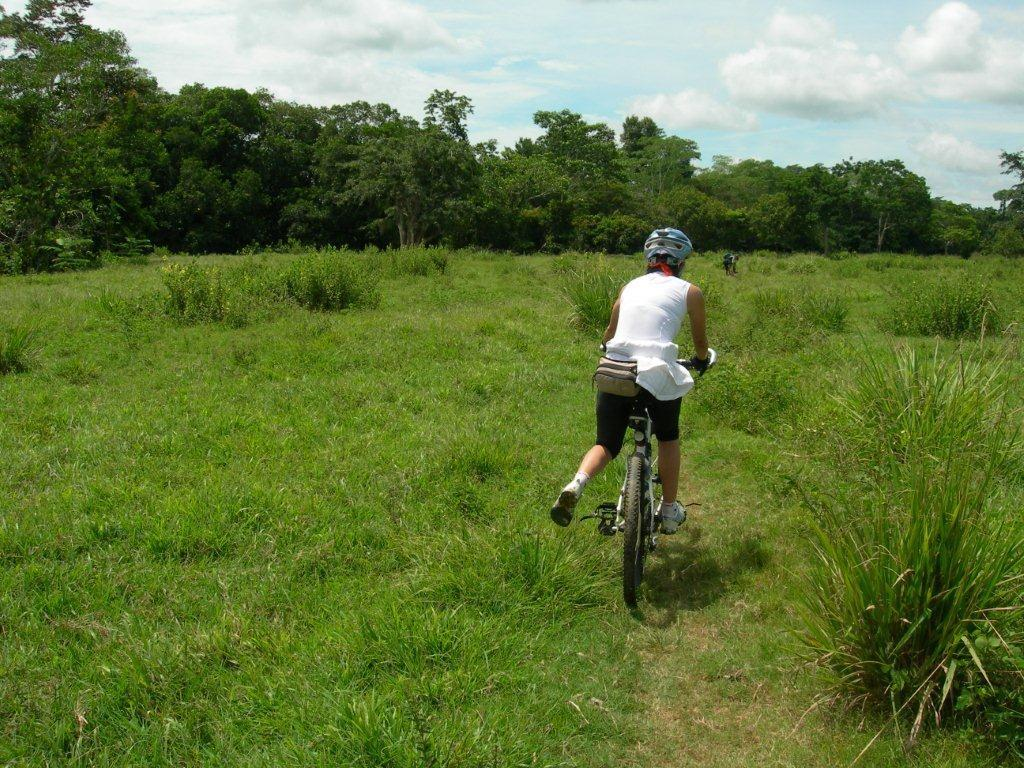What is the main activity of the person in the foreground of the image? The person in the foreground of the image is cycling. On what surface is the person cycling? The person is cycling on the grass. Can you describe the background of the image? In the background of the image, there is a person, grass, trees, and the sky. How many people are visible in the image? There are two people visible in the image. What type of vegetation is present in the background? There are trees in the background of the image. What type of fish can be seen swimming in the grass in the image? There are no fish present in the image, and fish do not swim in grass. 